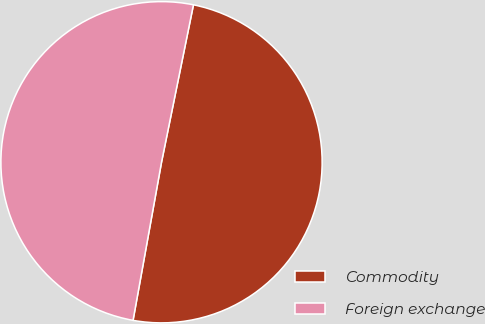Convert chart to OTSL. <chart><loc_0><loc_0><loc_500><loc_500><pie_chart><fcel>Commodity<fcel>Foreign exchange<nl><fcel>49.65%<fcel>50.35%<nl></chart> 